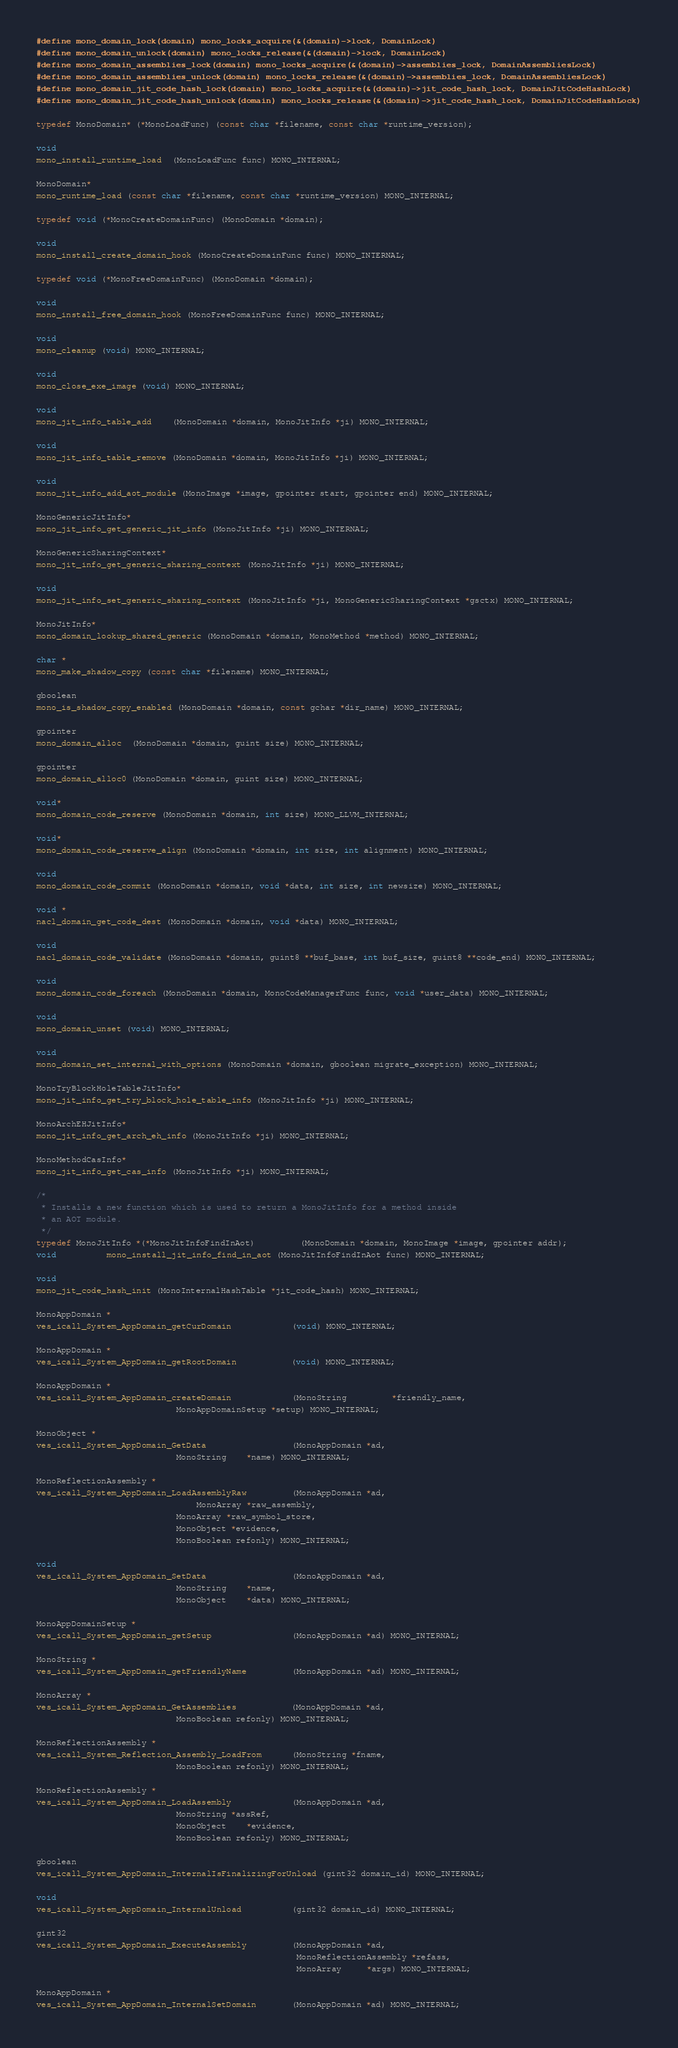<code> <loc_0><loc_0><loc_500><loc_500><_C_>
#define mono_domain_lock(domain) mono_locks_acquire(&(domain)->lock, DomainLock)
#define mono_domain_unlock(domain) mono_locks_release(&(domain)->lock, DomainLock)
#define mono_domain_assemblies_lock(domain) mono_locks_acquire(&(domain)->assemblies_lock, DomainAssembliesLock)
#define mono_domain_assemblies_unlock(domain) mono_locks_release(&(domain)->assemblies_lock, DomainAssembliesLock)
#define mono_domain_jit_code_hash_lock(domain) mono_locks_acquire(&(domain)->jit_code_hash_lock, DomainJitCodeHashLock)
#define mono_domain_jit_code_hash_unlock(domain) mono_locks_release(&(domain)->jit_code_hash_lock, DomainJitCodeHashLock)

typedef MonoDomain* (*MonoLoadFunc) (const char *filename, const char *runtime_version);

void
mono_install_runtime_load  (MonoLoadFunc func) MONO_INTERNAL;

MonoDomain*
mono_runtime_load (const char *filename, const char *runtime_version) MONO_INTERNAL;

typedef void (*MonoCreateDomainFunc) (MonoDomain *domain);

void
mono_install_create_domain_hook (MonoCreateDomainFunc func) MONO_INTERNAL;

typedef void (*MonoFreeDomainFunc) (MonoDomain *domain);

void
mono_install_free_domain_hook (MonoFreeDomainFunc func) MONO_INTERNAL;

void 
mono_cleanup (void) MONO_INTERNAL;

void
mono_close_exe_image (void) MONO_INTERNAL;

void
mono_jit_info_table_add    (MonoDomain *domain, MonoJitInfo *ji) MONO_INTERNAL;

void
mono_jit_info_table_remove (MonoDomain *domain, MonoJitInfo *ji) MONO_INTERNAL;

void
mono_jit_info_add_aot_module (MonoImage *image, gpointer start, gpointer end) MONO_INTERNAL;

MonoGenericJitInfo*
mono_jit_info_get_generic_jit_info (MonoJitInfo *ji) MONO_INTERNAL;

MonoGenericSharingContext*
mono_jit_info_get_generic_sharing_context (MonoJitInfo *ji) MONO_INTERNAL;

void
mono_jit_info_set_generic_sharing_context (MonoJitInfo *ji, MonoGenericSharingContext *gsctx) MONO_INTERNAL;

MonoJitInfo*
mono_domain_lookup_shared_generic (MonoDomain *domain, MonoMethod *method) MONO_INTERNAL;

char *
mono_make_shadow_copy (const char *filename) MONO_INTERNAL;

gboolean
mono_is_shadow_copy_enabled (MonoDomain *domain, const gchar *dir_name) MONO_INTERNAL;

gpointer
mono_domain_alloc  (MonoDomain *domain, guint size) MONO_INTERNAL;

gpointer
mono_domain_alloc0 (MonoDomain *domain, guint size) MONO_INTERNAL;

void*
mono_domain_code_reserve (MonoDomain *domain, int size) MONO_LLVM_INTERNAL;

void*
mono_domain_code_reserve_align (MonoDomain *domain, int size, int alignment) MONO_INTERNAL;

void
mono_domain_code_commit (MonoDomain *domain, void *data, int size, int newsize) MONO_INTERNAL;

void *
nacl_domain_get_code_dest (MonoDomain *domain, void *data) MONO_INTERNAL;

void 
nacl_domain_code_validate (MonoDomain *domain, guint8 **buf_base, int buf_size, guint8 **code_end) MONO_INTERNAL;

void
mono_domain_code_foreach (MonoDomain *domain, MonoCodeManagerFunc func, void *user_data) MONO_INTERNAL;

void
mono_domain_unset (void) MONO_INTERNAL;

void
mono_domain_set_internal_with_options (MonoDomain *domain, gboolean migrate_exception) MONO_INTERNAL;

MonoTryBlockHoleTableJitInfo*
mono_jit_info_get_try_block_hole_table_info (MonoJitInfo *ji) MONO_INTERNAL;

MonoArchEHJitInfo*
mono_jit_info_get_arch_eh_info (MonoJitInfo *ji) MONO_INTERNAL;

MonoMethodCasInfo*
mono_jit_info_get_cas_info (MonoJitInfo *ji) MONO_INTERNAL;

/* 
 * Installs a new function which is used to return a MonoJitInfo for a method inside
 * an AOT module.
 */
typedef MonoJitInfo *(*MonoJitInfoFindInAot)         (MonoDomain *domain, MonoImage *image, gpointer addr);
void          mono_install_jit_info_find_in_aot (MonoJitInfoFindInAot func) MONO_INTERNAL;

void
mono_jit_code_hash_init (MonoInternalHashTable *jit_code_hash) MONO_INTERNAL;

MonoAppDomain *
ves_icall_System_AppDomain_getCurDomain            (void) MONO_INTERNAL;

MonoAppDomain *
ves_icall_System_AppDomain_getRootDomain           (void) MONO_INTERNAL;

MonoAppDomain *
ves_icall_System_AppDomain_createDomain            (MonoString         *friendly_name,
						    MonoAppDomainSetup *setup) MONO_INTERNAL;

MonoObject *
ves_icall_System_AppDomain_GetData                 (MonoAppDomain *ad, 
						    MonoString    *name) MONO_INTERNAL;

MonoReflectionAssembly *
ves_icall_System_AppDomain_LoadAssemblyRaw         (MonoAppDomain *ad,
    						    MonoArray *raw_assembly, 
						    MonoArray *raw_symbol_store,
						    MonoObject *evidence,
						    MonoBoolean refonly) MONO_INTERNAL;

void
ves_icall_System_AppDomain_SetData                 (MonoAppDomain *ad, 
						    MonoString    *name, 
						    MonoObject    *data) MONO_INTERNAL;

MonoAppDomainSetup *
ves_icall_System_AppDomain_getSetup                (MonoAppDomain *ad) MONO_INTERNAL;

MonoString *
ves_icall_System_AppDomain_getFriendlyName         (MonoAppDomain *ad) MONO_INTERNAL;

MonoArray *
ves_icall_System_AppDomain_GetAssemblies           (MonoAppDomain *ad,
						    MonoBoolean refonly) MONO_INTERNAL;

MonoReflectionAssembly *
ves_icall_System_Reflection_Assembly_LoadFrom      (MonoString *fname,
						    MonoBoolean refonly) MONO_INTERNAL;

MonoReflectionAssembly *
ves_icall_System_AppDomain_LoadAssembly            (MonoAppDomain *ad, 
						    MonoString *assRef,
						    MonoObject    *evidence,
						    MonoBoolean refonly) MONO_INTERNAL;

gboolean
ves_icall_System_AppDomain_InternalIsFinalizingForUnload (gint32 domain_id) MONO_INTERNAL;

void
ves_icall_System_AppDomain_InternalUnload          (gint32 domain_id) MONO_INTERNAL;

gint32
ves_icall_System_AppDomain_ExecuteAssembly         (MonoAppDomain *ad, 
													MonoReflectionAssembly *refass,
													MonoArray     *args) MONO_INTERNAL;

MonoAppDomain * 
ves_icall_System_AppDomain_InternalSetDomain	   (MonoAppDomain *ad) MONO_INTERNAL;
</code> 